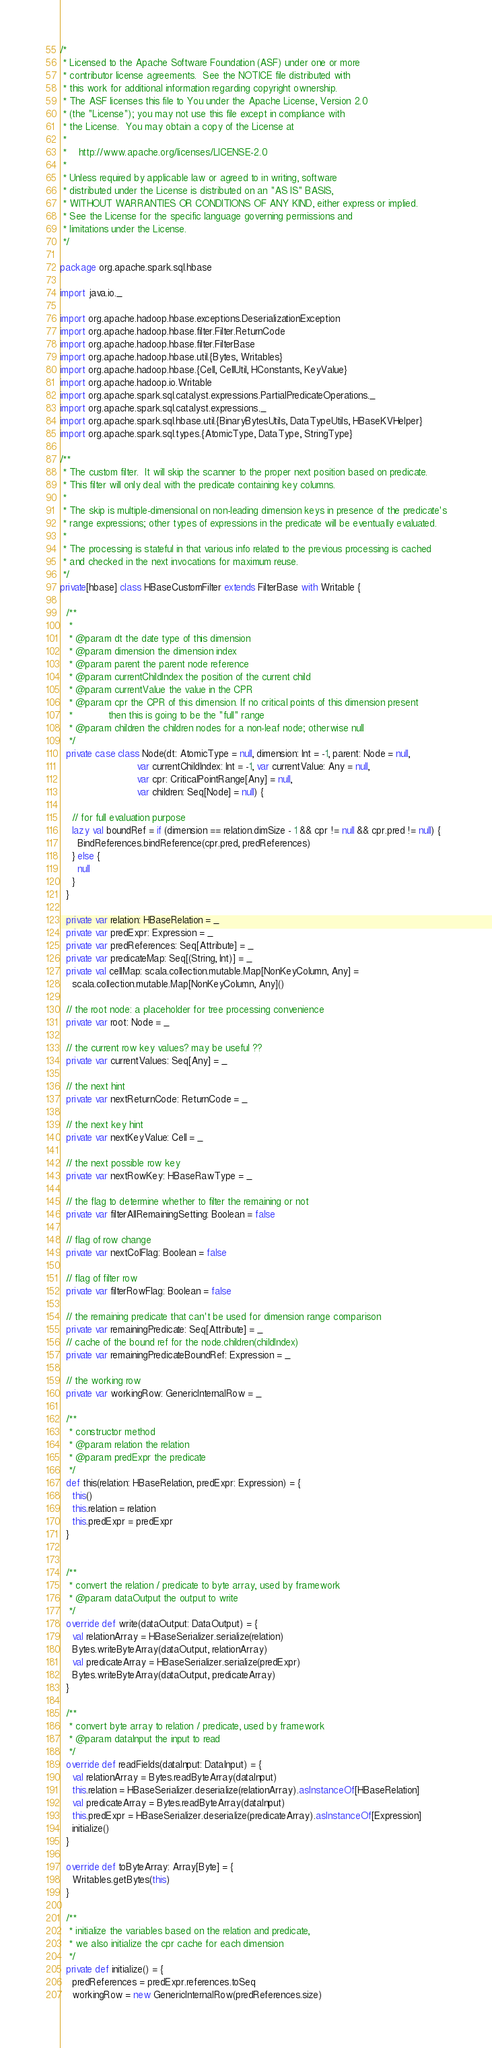Convert code to text. <code><loc_0><loc_0><loc_500><loc_500><_Scala_>/*
 * Licensed to the Apache Software Foundation (ASF) under one or more
 * contributor license agreements.  See the NOTICE file distributed with
 * this work for additional information regarding copyright ownership.
 * The ASF licenses this file to You under the Apache License, Version 2.0
 * (the "License"); you may not use this file except in compliance with
 * the License.  You may obtain a copy of the License at
 *
 *    http://www.apache.org/licenses/LICENSE-2.0
 *
 * Unless required by applicable law or agreed to in writing, software
 * distributed under the License is distributed on an "AS IS" BASIS,
 * WITHOUT WARRANTIES OR CONDITIONS OF ANY KIND, either express or implied.
 * See the License for the specific language governing permissions and
 * limitations under the License.
 */

package org.apache.spark.sql.hbase

import java.io._

import org.apache.hadoop.hbase.exceptions.DeserializationException
import org.apache.hadoop.hbase.filter.Filter.ReturnCode
import org.apache.hadoop.hbase.filter.FilterBase
import org.apache.hadoop.hbase.util.{Bytes, Writables}
import org.apache.hadoop.hbase.{Cell, CellUtil, HConstants, KeyValue}
import org.apache.hadoop.io.Writable
import org.apache.spark.sql.catalyst.expressions.PartialPredicateOperations._
import org.apache.spark.sql.catalyst.expressions._
import org.apache.spark.sql.hbase.util.{BinaryBytesUtils, DataTypeUtils, HBaseKVHelper}
import org.apache.spark.sql.types.{AtomicType, DataType, StringType}

/**
 * The custom filter.  It will skip the scanner to the proper next position based on predicate.
 * This filter will only deal with the predicate containing key columns.
 *
 * The skip is multiple-dimensional on non-leading dimension keys in presence of the predicate's
 * range expressions; other types of expressions in the predicate will be eventually evaluated.
 *
 * The processing is stateful in that various info related to the previous processing is cached
 * and checked in the next invocations for maximum reuse.
 */
private[hbase] class HBaseCustomFilter extends FilterBase with Writable {

  /**
   *
   * @param dt the date type of this dimension
   * @param dimension the dimension index
   * @param parent the parent node reference
   * @param currentChildIndex the position of the current child
   * @param currentValue the value in the CPR
   * @param cpr the CPR of this dimension. If no critical points of this dimension present
   *            then this is going to be the "full" range
   * @param children the children nodes for a non-leaf node; otherwise null
   */
  private case class Node(dt: AtomicType = null, dimension: Int = -1, parent: Node = null,
                          var currentChildIndex: Int = -1, var currentValue: Any = null,
                          var cpr: CriticalPointRange[Any] = null,
                          var children: Seq[Node] = null) {

    // for full evaluation purpose
    lazy val boundRef = if (dimension == relation.dimSize - 1 && cpr != null && cpr.pred != null) {
      BindReferences.bindReference(cpr.pred, predReferences)
    } else {
      null
    }
  }

  private var relation: HBaseRelation = _
  private var predExpr: Expression = _
  private var predReferences: Seq[Attribute] = _
  private var predicateMap: Seq[(String, Int)] = _
  private val cellMap: scala.collection.mutable.Map[NonKeyColumn, Any] =
    scala.collection.mutable.Map[NonKeyColumn, Any]()

  // the root node: a placeholder for tree processing convenience
  private var root: Node = _

  // the current row key values? may be useful ??
  private var currentValues: Seq[Any] = _

  // the next hint
  private var nextReturnCode: ReturnCode = _

  // the next key hint
  private var nextKeyValue: Cell = _

  // the next possible row key
  private var nextRowKey: HBaseRawType = _

  // the flag to determine whether to filter the remaining or not
  private var filterAllRemainingSetting: Boolean = false

  // flag of row change
  private var nextColFlag: Boolean = false

  // flag of filter row
  private var filterRowFlag: Boolean = false

  // the remaining predicate that can't be used for dimension range comparison
  private var remainingPredicate: Seq[Attribute] = _
  // cache of the bound ref for the node.children(childIndex)
  private var remainingPredicateBoundRef: Expression = _

  // the working row
  private var workingRow: GenericInternalRow = _

  /**
   * constructor method
   * @param relation the relation
   * @param predExpr the predicate
   */
  def this(relation: HBaseRelation, predExpr: Expression) = {
    this()
    this.relation = relation
    this.predExpr = predExpr
  }


  /**
   * convert the relation / predicate to byte array, used by framework
   * @param dataOutput the output to write
   */
  override def write(dataOutput: DataOutput) = {
    val relationArray = HBaseSerializer.serialize(relation)
    Bytes.writeByteArray(dataOutput, relationArray)
    val predicateArray = HBaseSerializer.serialize(predExpr)
    Bytes.writeByteArray(dataOutput, predicateArray)
  }

  /**
   * convert byte array to relation / predicate, used by framework
   * @param dataInput the input to read
   */
  override def readFields(dataInput: DataInput) = {
    val relationArray = Bytes.readByteArray(dataInput)
    this.relation = HBaseSerializer.deserialize(relationArray).asInstanceOf[HBaseRelation]
    val predicateArray = Bytes.readByteArray(dataInput)
    this.predExpr = HBaseSerializer.deserialize(predicateArray).asInstanceOf[Expression]
    initialize()
  }

  override def toByteArray: Array[Byte] = {
    Writables.getBytes(this)
  }

  /**
   * initialize the variables based on the relation and predicate,
   * we also initialize the cpr cache for each dimension
   */
  private def initialize() = {
    predReferences = predExpr.references.toSeq
    workingRow = new GenericInternalRow(predReferences.size)</code> 